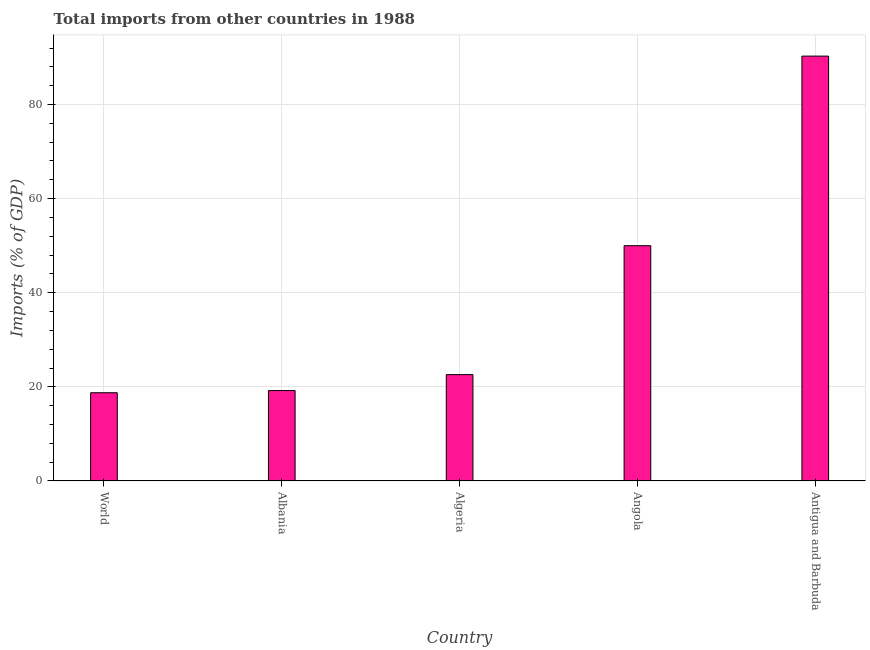Does the graph contain any zero values?
Give a very brief answer. No. What is the title of the graph?
Keep it short and to the point. Total imports from other countries in 1988. What is the label or title of the Y-axis?
Your response must be concise. Imports (% of GDP). What is the total imports in Albania?
Your response must be concise. 19.22. Across all countries, what is the maximum total imports?
Provide a short and direct response. 90.29. Across all countries, what is the minimum total imports?
Your response must be concise. 18.75. In which country was the total imports maximum?
Keep it short and to the point. Antigua and Barbuda. In which country was the total imports minimum?
Your answer should be compact. World. What is the sum of the total imports?
Your response must be concise. 200.86. What is the difference between the total imports in Albania and Algeria?
Give a very brief answer. -3.39. What is the average total imports per country?
Your response must be concise. 40.17. What is the median total imports?
Make the answer very short. 22.6. What is the ratio of the total imports in Albania to that in Angola?
Make the answer very short. 0.38. What is the difference between the highest and the second highest total imports?
Your answer should be very brief. 40.29. Is the sum of the total imports in Albania and Antigua and Barbuda greater than the maximum total imports across all countries?
Ensure brevity in your answer.  Yes. What is the difference between the highest and the lowest total imports?
Give a very brief answer. 71.54. In how many countries, is the total imports greater than the average total imports taken over all countries?
Keep it short and to the point. 2. How many bars are there?
Your response must be concise. 5. Are all the bars in the graph horizontal?
Offer a terse response. No. How many countries are there in the graph?
Offer a terse response. 5. What is the Imports (% of GDP) in World?
Provide a short and direct response. 18.75. What is the Imports (% of GDP) in Albania?
Offer a terse response. 19.22. What is the Imports (% of GDP) of Algeria?
Provide a short and direct response. 22.6. What is the Imports (% of GDP) of Antigua and Barbuda?
Offer a very short reply. 90.29. What is the difference between the Imports (% of GDP) in World and Albania?
Provide a short and direct response. -0.47. What is the difference between the Imports (% of GDP) in World and Algeria?
Provide a short and direct response. -3.85. What is the difference between the Imports (% of GDP) in World and Angola?
Offer a very short reply. -31.25. What is the difference between the Imports (% of GDP) in World and Antigua and Barbuda?
Ensure brevity in your answer.  -71.54. What is the difference between the Imports (% of GDP) in Albania and Algeria?
Your answer should be compact. -3.39. What is the difference between the Imports (% of GDP) in Albania and Angola?
Your response must be concise. -30.78. What is the difference between the Imports (% of GDP) in Albania and Antigua and Barbuda?
Keep it short and to the point. -71.07. What is the difference between the Imports (% of GDP) in Algeria and Angola?
Your response must be concise. -27.4. What is the difference between the Imports (% of GDP) in Algeria and Antigua and Barbuda?
Give a very brief answer. -67.68. What is the difference between the Imports (% of GDP) in Angola and Antigua and Barbuda?
Give a very brief answer. -40.29. What is the ratio of the Imports (% of GDP) in World to that in Albania?
Your answer should be very brief. 0.98. What is the ratio of the Imports (% of GDP) in World to that in Algeria?
Offer a terse response. 0.83. What is the ratio of the Imports (% of GDP) in World to that in Angola?
Make the answer very short. 0.38. What is the ratio of the Imports (% of GDP) in World to that in Antigua and Barbuda?
Your response must be concise. 0.21. What is the ratio of the Imports (% of GDP) in Albania to that in Angola?
Offer a terse response. 0.38. What is the ratio of the Imports (% of GDP) in Albania to that in Antigua and Barbuda?
Your answer should be very brief. 0.21. What is the ratio of the Imports (% of GDP) in Algeria to that in Angola?
Your answer should be very brief. 0.45. What is the ratio of the Imports (% of GDP) in Algeria to that in Antigua and Barbuda?
Keep it short and to the point. 0.25. What is the ratio of the Imports (% of GDP) in Angola to that in Antigua and Barbuda?
Ensure brevity in your answer.  0.55. 